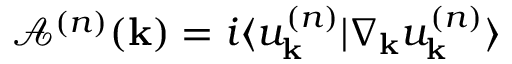Convert formula to latex. <formula><loc_0><loc_0><loc_500><loc_500>\mathcal { A } ^ { ( n ) } ( k ) = i \langle u _ { k } ^ { ( n ) } | \nabla _ { k } u _ { k } ^ { ( n ) } \rangle</formula> 